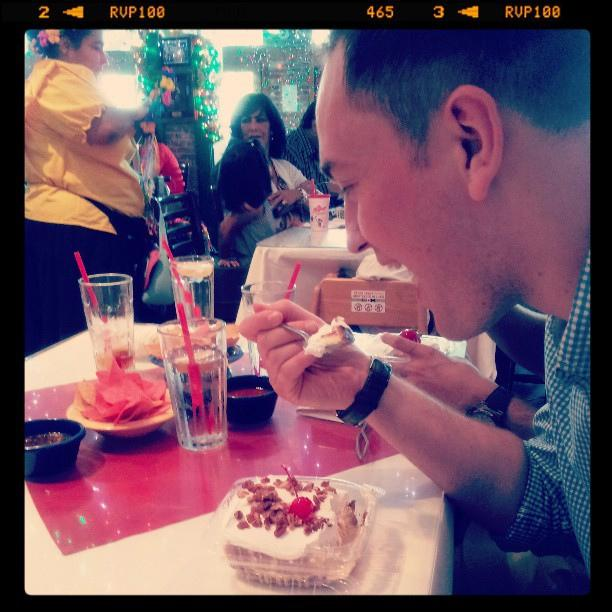What is the red object in the food the man is eating?

Choices:
A) apple
B) pepper
C) cherry
D) tomato cherry 